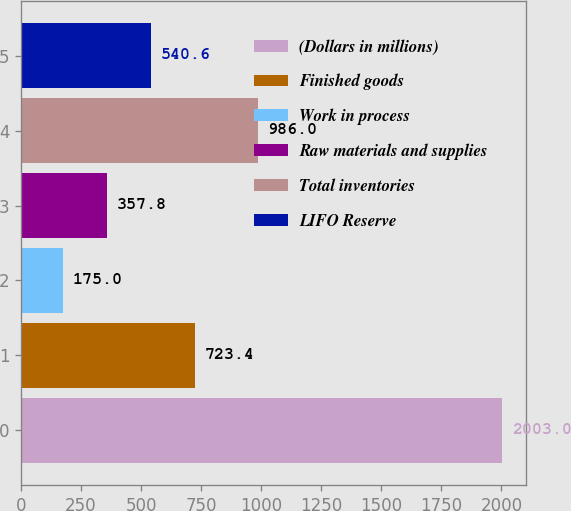Convert chart. <chart><loc_0><loc_0><loc_500><loc_500><bar_chart><fcel>(Dollars in millions)<fcel>Finished goods<fcel>Work in process<fcel>Raw materials and supplies<fcel>Total inventories<fcel>LIFO Reserve<nl><fcel>2003<fcel>723.4<fcel>175<fcel>357.8<fcel>986<fcel>540.6<nl></chart> 